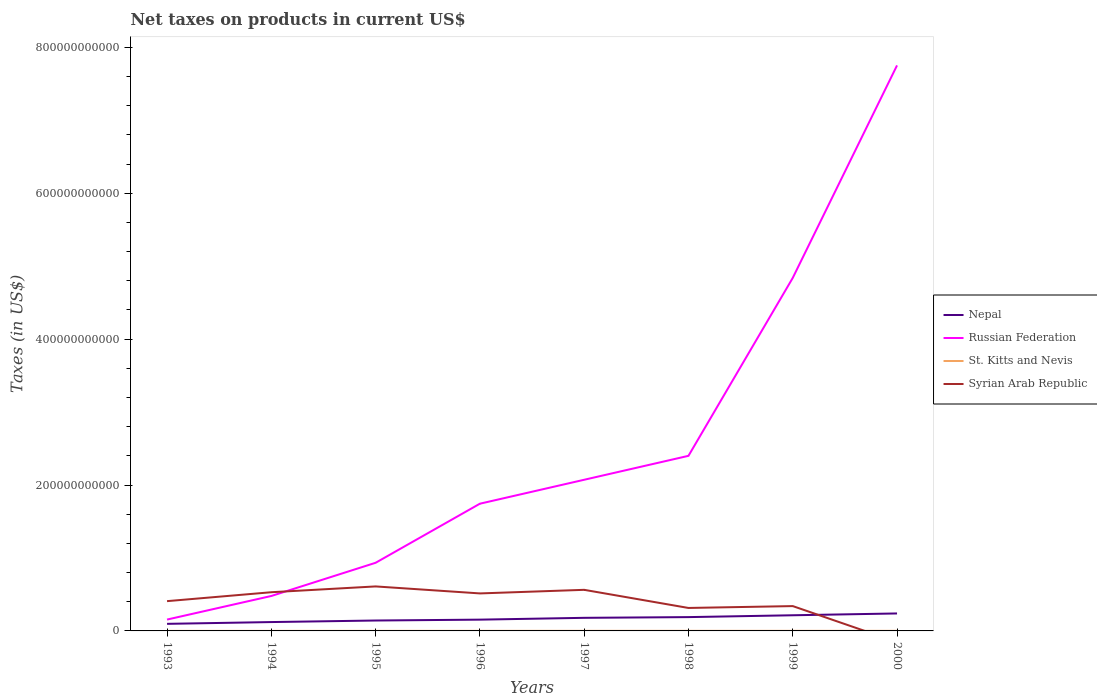Across all years, what is the maximum net taxes on products in St. Kitts and Nevis?
Offer a terse response. 6.36e+07. What is the total net taxes on products in Syrian Arab Republic in the graph?
Your answer should be compact. 9.59e+09. What is the difference between the highest and the second highest net taxes on products in Nepal?
Your answer should be compact. 1.42e+1. What is the difference between the highest and the lowest net taxes on products in St. Kitts and Nevis?
Give a very brief answer. 5. What is the difference between two consecutive major ticks on the Y-axis?
Provide a short and direct response. 2.00e+11. Are the values on the major ticks of Y-axis written in scientific E-notation?
Ensure brevity in your answer.  No. How many legend labels are there?
Keep it short and to the point. 4. What is the title of the graph?
Provide a succinct answer. Net taxes on products in current US$. What is the label or title of the X-axis?
Offer a very short reply. Years. What is the label or title of the Y-axis?
Give a very brief answer. Taxes (in US$). What is the Taxes (in US$) of Nepal in 1993?
Provide a short and direct response. 9.70e+09. What is the Taxes (in US$) in Russian Federation in 1993?
Give a very brief answer. 1.56e+1. What is the Taxes (in US$) in St. Kitts and Nevis in 1993?
Keep it short and to the point. 6.36e+07. What is the Taxes (in US$) in Syrian Arab Republic in 1993?
Your answer should be compact. 4.08e+1. What is the Taxes (in US$) in Nepal in 1994?
Ensure brevity in your answer.  1.21e+1. What is the Taxes (in US$) of Russian Federation in 1994?
Make the answer very short. 4.79e+1. What is the Taxes (in US$) in St. Kitts and Nevis in 1994?
Give a very brief answer. 6.94e+07. What is the Taxes (in US$) in Syrian Arab Republic in 1994?
Provide a short and direct response. 5.30e+1. What is the Taxes (in US$) in Nepal in 1995?
Ensure brevity in your answer.  1.43e+1. What is the Taxes (in US$) of Russian Federation in 1995?
Your response must be concise. 9.34e+1. What is the Taxes (in US$) of St. Kitts and Nevis in 1995?
Keep it short and to the point. 9.47e+07. What is the Taxes (in US$) in Syrian Arab Republic in 1995?
Keep it short and to the point. 6.10e+1. What is the Taxes (in US$) of Nepal in 1996?
Keep it short and to the point. 1.55e+1. What is the Taxes (in US$) in Russian Federation in 1996?
Ensure brevity in your answer.  1.74e+11. What is the Taxes (in US$) in St. Kitts and Nevis in 1996?
Provide a short and direct response. 1.05e+08. What is the Taxes (in US$) of Syrian Arab Republic in 1996?
Your answer should be compact. 5.14e+1. What is the Taxes (in US$) in Nepal in 1997?
Keep it short and to the point. 1.80e+1. What is the Taxes (in US$) of Russian Federation in 1997?
Your answer should be very brief. 2.07e+11. What is the Taxes (in US$) of St. Kitts and Nevis in 1997?
Make the answer very short. 1.19e+08. What is the Taxes (in US$) of Syrian Arab Republic in 1997?
Your response must be concise. 5.63e+1. What is the Taxes (in US$) of Nepal in 1998?
Offer a very short reply. 1.89e+1. What is the Taxes (in US$) in Russian Federation in 1998?
Provide a short and direct response. 2.40e+11. What is the Taxes (in US$) of St. Kitts and Nevis in 1998?
Offer a very short reply. 1.23e+08. What is the Taxes (in US$) in Syrian Arab Republic in 1998?
Your response must be concise. 3.15e+1. What is the Taxes (in US$) in Nepal in 1999?
Offer a very short reply. 2.15e+1. What is the Taxes (in US$) of Russian Federation in 1999?
Offer a very short reply. 4.84e+11. What is the Taxes (in US$) in St. Kitts and Nevis in 1999?
Give a very brief answer. 1.29e+08. What is the Taxes (in US$) in Syrian Arab Republic in 1999?
Your response must be concise. 3.40e+1. What is the Taxes (in US$) in Nepal in 2000?
Your response must be concise. 2.39e+1. What is the Taxes (in US$) in Russian Federation in 2000?
Make the answer very short. 7.75e+11. What is the Taxes (in US$) of St. Kitts and Nevis in 2000?
Your answer should be very brief. 1.19e+08. Across all years, what is the maximum Taxes (in US$) in Nepal?
Your answer should be compact. 2.39e+1. Across all years, what is the maximum Taxes (in US$) in Russian Federation?
Give a very brief answer. 7.75e+11. Across all years, what is the maximum Taxes (in US$) of St. Kitts and Nevis?
Provide a succinct answer. 1.29e+08. Across all years, what is the maximum Taxes (in US$) of Syrian Arab Republic?
Provide a succinct answer. 6.10e+1. Across all years, what is the minimum Taxes (in US$) of Nepal?
Ensure brevity in your answer.  9.70e+09. Across all years, what is the minimum Taxes (in US$) of Russian Federation?
Provide a short and direct response. 1.56e+1. Across all years, what is the minimum Taxes (in US$) in St. Kitts and Nevis?
Your response must be concise. 6.36e+07. What is the total Taxes (in US$) in Nepal in the graph?
Provide a short and direct response. 1.34e+11. What is the total Taxes (in US$) in Russian Federation in the graph?
Offer a terse response. 2.04e+12. What is the total Taxes (in US$) of St. Kitts and Nevis in the graph?
Your response must be concise. 8.23e+08. What is the total Taxes (in US$) in Syrian Arab Republic in the graph?
Your response must be concise. 3.28e+11. What is the difference between the Taxes (in US$) in Nepal in 1993 and that in 1994?
Give a very brief answer. -2.45e+09. What is the difference between the Taxes (in US$) in Russian Federation in 1993 and that in 1994?
Offer a terse response. -3.23e+1. What is the difference between the Taxes (in US$) of St. Kitts and Nevis in 1993 and that in 1994?
Provide a short and direct response. -5.82e+06. What is the difference between the Taxes (in US$) of Syrian Arab Republic in 1993 and that in 1994?
Your answer should be compact. -1.22e+1. What is the difference between the Taxes (in US$) in Nepal in 1993 and that in 1995?
Provide a succinct answer. -4.56e+09. What is the difference between the Taxes (in US$) in Russian Federation in 1993 and that in 1995?
Provide a succinct answer. -7.78e+1. What is the difference between the Taxes (in US$) of St. Kitts and Nevis in 1993 and that in 1995?
Offer a terse response. -3.11e+07. What is the difference between the Taxes (in US$) in Syrian Arab Republic in 1993 and that in 1995?
Provide a short and direct response. -2.02e+1. What is the difference between the Taxes (in US$) of Nepal in 1993 and that in 1996?
Your answer should be very brief. -5.76e+09. What is the difference between the Taxes (in US$) in Russian Federation in 1993 and that in 1996?
Provide a succinct answer. -1.59e+11. What is the difference between the Taxes (in US$) of St. Kitts and Nevis in 1993 and that in 1996?
Your answer should be compact. -4.15e+07. What is the difference between the Taxes (in US$) in Syrian Arab Republic in 1993 and that in 1996?
Your answer should be compact. -1.06e+1. What is the difference between the Taxes (in US$) of Nepal in 1993 and that in 1997?
Make the answer very short. -8.25e+09. What is the difference between the Taxes (in US$) in Russian Federation in 1993 and that in 1997?
Offer a terse response. -1.92e+11. What is the difference between the Taxes (in US$) in St. Kitts and Nevis in 1993 and that in 1997?
Offer a terse response. -5.52e+07. What is the difference between the Taxes (in US$) in Syrian Arab Republic in 1993 and that in 1997?
Offer a very short reply. -1.55e+1. What is the difference between the Taxes (in US$) of Nepal in 1993 and that in 1998?
Ensure brevity in your answer.  -9.24e+09. What is the difference between the Taxes (in US$) in Russian Federation in 1993 and that in 1998?
Make the answer very short. -2.24e+11. What is the difference between the Taxes (in US$) in St. Kitts and Nevis in 1993 and that in 1998?
Provide a short and direct response. -5.97e+07. What is the difference between the Taxes (in US$) of Syrian Arab Republic in 1993 and that in 1998?
Your response must be concise. 9.34e+09. What is the difference between the Taxes (in US$) in Nepal in 1993 and that in 1999?
Offer a terse response. -1.18e+1. What is the difference between the Taxes (in US$) in Russian Federation in 1993 and that in 1999?
Your answer should be very brief. -4.68e+11. What is the difference between the Taxes (in US$) in St. Kitts and Nevis in 1993 and that in 1999?
Make the answer very short. -6.53e+07. What is the difference between the Taxes (in US$) in Syrian Arab Republic in 1993 and that in 1999?
Provide a succinct answer. 6.78e+09. What is the difference between the Taxes (in US$) in Nepal in 1993 and that in 2000?
Keep it short and to the point. -1.42e+1. What is the difference between the Taxes (in US$) in Russian Federation in 1993 and that in 2000?
Offer a terse response. -7.60e+11. What is the difference between the Taxes (in US$) in St. Kitts and Nevis in 1993 and that in 2000?
Make the answer very short. -5.50e+07. What is the difference between the Taxes (in US$) of Nepal in 1994 and that in 1995?
Give a very brief answer. -2.11e+09. What is the difference between the Taxes (in US$) in Russian Federation in 1994 and that in 1995?
Make the answer very short. -4.55e+1. What is the difference between the Taxes (in US$) in St. Kitts and Nevis in 1994 and that in 1995?
Provide a short and direct response. -2.53e+07. What is the difference between the Taxes (in US$) in Syrian Arab Republic in 1994 and that in 1995?
Offer a terse response. -7.96e+09. What is the difference between the Taxes (in US$) in Nepal in 1994 and that in 1996?
Keep it short and to the point. -3.31e+09. What is the difference between the Taxes (in US$) of Russian Federation in 1994 and that in 1996?
Your answer should be compact. -1.27e+11. What is the difference between the Taxes (in US$) of St. Kitts and Nevis in 1994 and that in 1996?
Your answer should be very brief. -3.57e+07. What is the difference between the Taxes (in US$) of Syrian Arab Republic in 1994 and that in 1996?
Your response must be concise. 1.63e+09. What is the difference between the Taxes (in US$) of Nepal in 1994 and that in 1997?
Provide a short and direct response. -5.80e+09. What is the difference between the Taxes (in US$) in Russian Federation in 1994 and that in 1997?
Give a very brief answer. -1.59e+11. What is the difference between the Taxes (in US$) of St. Kitts and Nevis in 1994 and that in 1997?
Offer a terse response. -4.94e+07. What is the difference between the Taxes (in US$) of Syrian Arab Republic in 1994 and that in 1997?
Your answer should be compact. -3.28e+09. What is the difference between the Taxes (in US$) of Nepal in 1994 and that in 1998?
Make the answer very short. -6.79e+09. What is the difference between the Taxes (in US$) of Russian Federation in 1994 and that in 1998?
Your answer should be very brief. -1.92e+11. What is the difference between the Taxes (in US$) in St. Kitts and Nevis in 1994 and that in 1998?
Ensure brevity in your answer.  -5.39e+07. What is the difference between the Taxes (in US$) of Syrian Arab Republic in 1994 and that in 1998?
Provide a short and direct response. 2.16e+1. What is the difference between the Taxes (in US$) in Nepal in 1994 and that in 1999?
Your response must be concise. -9.31e+09. What is the difference between the Taxes (in US$) in Russian Federation in 1994 and that in 1999?
Make the answer very short. -4.36e+11. What is the difference between the Taxes (in US$) of St. Kitts and Nevis in 1994 and that in 1999?
Provide a short and direct response. -5.95e+07. What is the difference between the Taxes (in US$) of Syrian Arab Republic in 1994 and that in 1999?
Give a very brief answer. 1.90e+1. What is the difference between the Taxes (in US$) of Nepal in 1994 and that in 2000?
Your answer should be compact. -1.18e+1. What is the difference between the Taxes (in US$) in Russian Federation in 1994 and that in 2000?
Ensure brevity in your answer.  -7.27e+11. What is the difference between the Taxes (in US$) of St. Kitts and Nevis in 1994 and that in 2000?
Your response must be concise. -4.92e+07. What is the difference between the Taxes (in US$) of Nepal in 1995 and that in 1996?
Make the answer very short. -1.20e+09. What is the difference between the Taxes (in US$) in Russian Federation in 1995 and that in 1996?
Make the answer very short. -8.10e+1. What is the difference between the Taxes (in US$) in St. Kitts and Nevis in 1995 and that in 1996?
Offer a terse response. -1.04e+07. What is the difference between the Taxes (in US$) in Syrian Arab Republic in 1995 and that in 1996?
Ensure brevity in your answer.  9.59e+09. What is the difference between the Taxes (in US$) in Nepal in 1995 and that in 1997?
Keep it short and to the point. -3.69e+09. What is the difference between the Taxes (in US$) in Russian Federation in 1995 and that in 1997?
Provide a short and direct response. -1.14e+11. What is the difference between the Taxes (in US$) in St. Kitts and Nevis in 1995 and that in 1997?
Ensure brevity in your answer.  -2.41e+07. What is the difference between the Taxes (in US$) of Syrian Arab Republic in 1995 and that in 1997?
Give a very brief answer. 4.68e+09. What is the difference between the Taxes (in US$) in Nepal in 1995 and that in 1998?
Keep it short and to the point. -4.68e+09. What is the difference between the Taxes (in US$) of Russian Federation in 1995 and that in 1998?
Ensure brevity in your answer.  -1.47e+11. What is the difference between the Taxes (in US$) in St. Kitts and Nevis in 1995 and that in 1998?
Provide a short and direct response. -2.86e+07. What is the difference between the Taxes (in US$) of Syrian Arab Republic in 1995 and that in 1998?
Keep it short and to the point. 2.95e+1. What is the difference between the Taxes (in US$) of Nepal in 1995 and that in 1999?
Offer a terse response. -7.20e+09. What is the difference between the Taxes (in US$) of Russian Federation in 1995 and that in 1999?
Your answer should be very brief. -3.90e+11. What is the difference between the Taxes (in US$) of St. Kitts and Nevis in 1995 and that in 1999?
Your response must be concise. -3.42e+07. What is the difference between the Taxes (in US$) in Syrian Arab Republic in 1995 and that in 1999?
Provide a succinct answer. 2.70e+1. What is the difference between the Taxes (in US$) of Nepal in 1995 and that in 2000?
Give a very brief answer. -9.68e+09. What is the difference between the Taxes (in US$) of Russian Federation in 1995 and that in 2000?
Offer a very short reply. -6.82e+11. What is the difference between the Taxes (in US$) in St. Kitts and Nevis in 1995 and that in 2000?
Ensure brevity in your answer.  -2.39e+07. What is the difference between the Taxes (in US$) of Nepal in 1996 and that in 1997?
Your answer should be very brief. -2.50e+09. What is the difference between the Taxes (in US$) of Russian Federation in 1996 and that in 1997?
Your response must be concise. -3.28e+1. What is the difference between the Taxes (in US$) of St. Kitts and Nevis in 1996 and that in 1997?
Make the answer very short. -1.37e+07. What is the difference between the Taxes (in US$) in Syrian Arab Republic in 1996 and that in 1997?
Keep it short and to the point. -4.91e+09. What is the difference between the Taxes (in US$) of Nepal in 1996 and that in 1998?
Give a very brief answer. -3.49e+09. What is the difference between the Taxes (in US$) in Russian Federation in 1996 and that in 1998?
Your response must be concise. -6.56e+1. What is the difference between the Taxes (in US$) of St. Kitts and Nevis in 1996 and that in 1998?
Your answer should be compact. -1.82e+07. What is the difference between the Taxes (in US$) of Syrian Arab Republic in 1996 and that in 1998?
Provide a succinct answer. 1.99e+1. What is the difference between the Taxes (in US$) of Nepal in 1996 and that in 1999?
Offer a very short reply. -6.00e+09. What is the difference between the Taxes (in US$) in Russian Federation in 1996 and that in 1999?
Your response must be concise. -3.10e+11. What is the difference between the Taxes (in US$) of St. Kitts and Nevis in 1996 and that in 1999?
Keep it short and to the point. -2.38e+07. What is the difference between the Taxes (in US$) of Syrian Arab Republic in 1996 and that in 1999?
Offer a very short reply. 1.74e+1. What is the difference between the Taxes (in US$) in Nepal in 1996 and that in 2000?
Your response must be concise. -8.49e+09. What is the difference between the Taxes (in US$) in Russian Federation in 1996 and that in 2000?
Your answer should be compact. -6.01e+11. What is the difference between the Taxes (in US$) in St. Kitts and Nevis in 1996 and that in 2000?
Give a very brief answer. -1.35e+07. What is the difference between the Taxes (in US$) in Nepal in 1997 and that in 1998?
Make the answer very short. -9.91e+08. What is the difference between the Taxes (in US$) of Russian Federation in 1997 and that in 1998?
Ensure brevity in your answer.  -3.28e+1. What is the difference between the Taxes (in US$) in St. Kitts and Nevis in 1997 and that in 1998?
Make the answer very short. -4.53e+06. What is the difference between the Taxes (in US$) in Syrian Arab Republic in 1997 and that in 1998?
Provide a succinct answer. 2.49e+1. What is the difference between the Taxes (in US$) of Nepal in 1997 and that in 1999?
Provide a succinct answer. -3.50e+09. What is the difference between the Taxes (in US$) of Russian Federation in 1997 and that in 1999?
Offer a terse response. -2.77e+11. What is the difference between the Taxes (in US$) in St. Kitts and Nevis in 1997 and that in 1999?
Give a very brief answer. -1.01e+07. What is the difference between the Taxes (in US$) of Syrian Arab Republic in 1997 and that in 1999?
Your response must be concise. 2.23e+1. What is the difference between the Taxes (in US$) in Nepal in 1997 and that in 2000?
Make the answer very short. -5.99e+09. What is the difference between the Taxes (in US$) in Russian Federation in 1997 and that in 2000?
Provide a succinct answer. -5.68e+11. What is the difference between the Taxes (in US$) in St. Kitts and Nevis in 1997 and that in 2000?
Keep it short and to the point. 1.90e+05. What is the difference between the Taxes (in US$) in Nepal in 1998 and that in 1999?
Provide a succinct answer. -2.51e+09. What is the difference between the Taxes (in US$) of Russian Federation in 1998 and that in 1999?
Offer a terse response. -2.44e+11. What is the difference between the Taxes (in US$) in St. Kitts and Nevis in 1998 and that in 1999?
Keep it short and to the point. -5.56e+06. What is the difference between the Taxes (in US$) of Syrian Arab Republic in 1998 and that in 1999?
Your answer should be very brief. -2.56e+09. What is the difference between the Taxes (in US$) in Nepal in 1998 and that in 2000?
Give a very brief answer. -5.00e+09. What is the difference between the Taxes (in US$) of Russian Federation in 1998 and that in 2000?
Keep it short and to the point. -5.35e+11. What is the difference between the Taxes (in US$) of St. Kitts and Nevis in 1998 and that in 2000?
Give a very brief answer. 4.72e+06. What is the difference between the Taxes (in US$) in Nepal in 1999 and that in 2000?
Keep it short and to the point. -2.49e+09. What is the difference between the Taxes (in US$) of Russian Federation in 1999 and that in 2000?
Provide a succinct answer. -2.91e+11. What is the difference between the Taxes (in US$) in St. Kitts and Nevis in 1999 and that in 2000?
Ensure brevity in your answer.  1.03e+07. What is the difference between the Taxes (in US$) in Nepal in 1993 and the Taxes (in US$) in Russian Federation in 1994?
Make the answer very short. -3.82e+1. What is the difference between the Taxes (in US$) of Nepal in 1993 and the Taxes (in US$) of St. Kitts and Nevis in 1994?
Ensure brevity in your answer.  9.63e+09. What is the difference between the Taxes (in US$) in Nepal in 1993 and the Taxes (in US$) in Syrian Arab Republic in 1994?
Your answer should be very brief. -4.33e+1. What is the difference between the Taxes (in US$) in Russian Federation in 1993 and the Taxes (in US$) in St. Kitts and Nevis in 1994?
Offer a very short reply. 1.55e+1. What is the difference between the Taxes (in US$) in Russian Federation in 1993 and the Taxes (in US$) in Syrian Arab Republic in 1994?
Your answer should be very brief. -3.75e+1. What is the difference between the Taxes (in US$) of St. Kitts and Nevis in 1993 and the Taxes (in US$) of Syrian Arab Republic in 1994?
Keep it short and to the point. -5.30e+1. What is the difference between the Taxes (in US$) of Nepal in 1993 and the Taxes (in US$) of Russian Federation in 1995?
Provide a succinct answer. -8.37e+1. What is the difference between the Taxes (in US$) of Nepal in 1993 and the Taxes (in US$) of St. Kitts and Nevis in 1995?
Your answer should be very brief. 9.61e+09. What is the difference between the Taxes (in US$) in Nepal in 1993 and the Taxes (in US$) in Syrian Arab Republic in 1995?
Provide a short and direct response. -5.13e+1. What is the difference between the Taxes (in US$) in Russian Federation in 1993 and the Taxes (in US$) in St. Kitts and Nevis in 1995?
Ensure brevity in your answer.  1.55e+1. What is the difference between the Taxes (in US$) of Russian Federation in 1993 and the Taxes (in US$) of Syrian Arab Republic in 1995?
Give a very brief answer. -4.54e+1. What is the difference between the Taxes (in US$) in St. Kitts and Nevis in 1993 and the Taxes (in US$) in Syrian Arab Republic in 1995?
Offer a terse response. -6.09e+1. What is the difference between the Taxes (in US$) in Nepal in 1993 and the Taxes (in US$) in Russian Federation in 1996?
Your response must be concise. -1.65e+11. What is the difference between the Taxes (in US$) of Nepal in 1993 and the Taxes (in US$) of St. Kitts and Nevis in 1996?
Ensure brevity in your answer.  9.60e+09. What is the difference between the Taxes (in US$) in Nepal in 1993 and the Taxes (in US$) in Syrian Arab Republic in 1996?
Offer a very short reply. -4.17e+1. What is the difference between the Taxes (in US$) in Russian Federation in 1993 and the Taxes (in US$) in St. Kitts and Nevis in 1996?
Ensure brevity in your answer.  1.55e+1. What is the difference between the Taxes (in US$) of Russian Federation in 1993 and the Taxes (in US$) of Syrian Arab Republic in 1996?
Provide a short and direct response. -3.59e+1. What is the difference between the Taxes (in US$) of St. Kitts and Nevis in 1993 and the Taxes (in US$) of Syrian Arab Republic in 1996?
Keep it short and to the point. -5.13e+1. What is the difference between the Taxes (in US$) of Nepal in 1993 and the Taxes (in US$) of Russian Federation in 1997?
Your answer should be compact. -1.97e+11. What is the difference between the Taxes (in US$) in Nepal in 1993 and the Taxes (in US$) in St. Kitts and Nevis in 1997?
Your answer should be very brief. 9.58e+09. What is the difference between the Taxes (in US$) in Nepal in 1993 and the Taxes (in US$) in Syrian Arab Republic in 1997?
Your answer should be compact. -4.66e+1. What is the difference between the Taxes (in US$) of Russian Federation in 1993 and the Taxes (in US$) of St. Kitts and Nevis in 1997?
Provide a short and direct response. 1.54e+1. What is the difference between the Taxes (in US$) in Russian Federation in 1993 and the Taxes (in US$) in Syrian Arab Republic in 1997?
Offer a terse response. -4.08e+1. What is the difference between the Taxes (in US$) of St. Kitts and Nevis in 1993 and the Taxes (in US$) of Syrian Arab Republic in 1997?
Make the answer very short. -5.63e+1. What is the difference between the Taxes (in US$) of Nepal in 1993 and the Taxes (in US$) of Russian Federation in 1998?
Provide a succinct answer. -2.30e+11. What is the difference between the Taxes (in US$) in Nepal in 1993 and the Taxes (in US$) in St. Kitts and Nevis in 1998?
Ensure brevity in your answer.  9.58e+09. What is the difference between the Taxes (in US$) of Nepal in 1993 and the Taxes (in US$) of Syrian Arab Republic in 1998?
Provide a succinct answer. -2.18e+1. What is the difference between the Taxes (in US$) in Russian Federation in 1993 and the Taxes (in US$) in St. Kitts and Nevis in 1998?
Your answer should be very brief. 1.54e+1. What is the difference between the Taxes (in US$) in Russian Federation in 1993 and the Taxes (in US$) in Syrian Arab Republic in 1998?
Your answer should be very brief. -1.59e+1. What is the difference between the Taxes (in US$) in St. Kitts and Nevis in 1993 and the Taxes (in US$) in Syrian Arab Republic in 1998?
Make the answer very short. -3.14e+1. What is the difference between the Taxes (in US$) in Nepal in 1993 and the Taxes (in US$) in Russian Federation in 1999?
Make the answer very short. -4.74e+11. What is the difference between the Taxes (in US$) of Nepal in 1993 and the Taxes (in US$) of St. Kitts and Nevis in 1999?
Your response must be concise. 9.57e+09. What is the difference between the Taxes (in US$) in Nepal in 1993 and the Taxes (in US$) in Syrian Arab Republic in 1999?
Give a very brief answer. -2.43e+1. What is the difference between the Taxes (in US$) of Russian Federation in 1993 and the Taxes (in US$) of St. Kitts and Nevis in 1999?
Offer a very short reply. 1.54e+1. What is the difference between the Taxes (in US$) in Russian Federation in 1993 and the Taxes (in US$) in Syrian Arab Republic in 1999?
Make the answer very short. -1.85e+1. What is the difference between the Taxes (in US$) of St. Kitts and Nevis in 1993 and the Taxes (in US$) of Syrian Arab Republic in 1999?
Ensure brevity in your answer.  -3.40e+1. What is the difference between the Taxes (in US$) of Nepal in 1993 and the Taxes (in US$) of Russian Federation in 2000?
Give a very brief answer. -7.65e+11. What is the difference between the Taxes (in US$) of Nepal in 1993 and the Taxes (in US$) of St. Kitts and Nevis in 2000?
Provide a succinct answer. 9.58e+09. What is the difference between the Taxes (in US$) in Russian Federation in 1993 and the Taxes (in US$) in St. Kitts and Nevis in 2000?
Your response must be concise. 1.54e+1. What is the difference between the Taxes (in US$) in Nepal in 1994 and the Taxes (in US$) in Russian Federation in 1995?
Provide a short and direct response. -8.13e+1. What is the difference between the Taxes (in US$) in Nepal in 1994 and the Taxes (in US$) in St. Kitts and Nevis in 1995?
Give a very brief answer. 1.21e+1. What is the difference between the Taxes (in US$) in Nepal in 1994 and the Taxes (in US$) in Syrian Arab Republic in 1995?
Offer a terse response. -4.89e+1. What is the difference between the Taxes (in US$) of Russian Federation in 1994 and the Taxes (in US$) of St. Kitts and Nevis in 1995?
Give a very brief answer. 4.78e+1. What is the difference between the Taxes (in US$) of Russian Federation in 1994 and the Taxes (in US$) of Syrian Arab Republic in 1995?
Your response must be concise. -1.31e+1. What is the difference between the Taxes (in US$) of St. Kitts and Nevis in 1994 and the Taxes (in US$) of Syrian Arab Republic in 1995?
Your response must be concise. -6.09e+1. What is the difference between the Taxes (in US$) of Nepal in 1994 and the Taxes (in US$) of Russian Federation in 1996?
Make the answer very short. -1.62e+11. What is the difference between the Taxes (in US$) in Nepal in 1994 and the Taxes (in US$) in St. Kitts and Nevis in 1996?
Offer a terse response. 1.20e+1. What is the difference between the Taxes (in US$) of Nepal in 1994 and the Taxes (in US$) of Syrian Arab Republic in 1996?
Keep it short and to the point. -3.93e+1. What is the difference between the Taxes (in US$) in Russian Federation in 1994 and the Taxes (in US$) in St. Kitts and Nevis in 1996?
Give a very brief answer. 4.78e+1. What is the difference between the Taxes (in US$) in Russian Federation in 1994 and the Taxes (in US$) in Syrian Arab Republic in 1996?
Provide a succinct answer. -3.51e+09. What is the difference between the Taxes (in US$) in St. Kitts and Nevis in 1994 and the Taxes (in US$) in Syrian Arab Republic in 1996?
Keep it short and to the point. -5.13e+1. What is the difference between the Taxes (in US$) of Nepal in 1994 and the Taxes (in US$) of Russian Federation in 1997?
Your response must be concise. -1.95e+11. What is the difference between the Taxes (in US$) of Nepal in 1994 and the Taxes (in US$) of St. Kitts and Nevis in 1997?
Provide a short and direct response. 1.20e+1. What is the difference between the Taxes (in US$) in Nepal in 1994 and the Taxes (in US$) in Syrian Arab Republic in 1997?
Provide a succinct answer. -4.42e+1. What is the difference between the Taxes (in US$) in Russian Federation in 1994 and the Taxes (in US$) in St. Kitts and Nevis in 1997?
Provide a succinct answer. 4.78e+1. What is the difference between the Taxes (in US$) in Russian Federation in 1994 and the Taxes (in US$) in Syrian Arab Republic in 1997?
Your answer should be very brief. -8.43e+09. What is the difference between the Taxes (in US$) in St. Kitts and Nevis in 1994 and the Taxes (in US$) in Syrian Arab Republic in 1997?
Your response must be concise. -5.63e+1. What is the difference between the Taxes (in US$) in Nepal in 1994 and the Taxes (in US$) in Russian Federation in 1998?
Keep it short and to the point. -2.28e+11. What is the difference between the Taxes (in US$) of Nepal in 1994 and the Taxes (in US$) of St. Kitts and Nevis in 1998?
Make the answer very short. 1.20e+1. What is the difference between the Taxes (in US$) in Nepal in 1994 and the Taxes (in US$) in Syrian Arab Republic in 1998?
Keep it short and to the point. -1.93e+1. What is the difference between the Taxes (in US$) of Russian Federation in 1994 and the Taxes (in US$) of St. Kitts and Nevis in 1998?
Offer a terse response. 4.78e+1. What is the difference between the Taxes (in US$) of Russian Federation in 1994 and the Taxes (in US$) of Syrian Arab Republic in 1998?
Offer a terse response. 1.64e+1. What is the difference between the Taxes (in US$) in St. Kitts and Nevis in 1994 and the Taxes (in US$) in Syrian Arab Republic in 1998?
Your answer should be very brief. -3.14e+1. What is the difference between the Taxes (in US$) in Nepal in 1994 and the Taxes (in US$) in Russian Federation in 1999?
Your answer should be compact. -4.72e+11. What is the difference between the Taxes (in US$) of Nepal in 1994 and the Taxes (in US$) of St. Kitts and Nevis in 1999?
Your response must be concise. 1.20e+1. What is the difference between the Taxes (in US$) in Nepal in 1994 and the Taxes (in US$) in Syrian Arab Republic in 1999?
Offer a very short reply. -2.19e+1. What is the difference between the Taxes (in US$) of Russian Federation in 1994 and the Taxes (in US$) of St. Kitts and Nevis in 1999?
Offer a very short reply. 4.78e+1. What is the difference between the Taxes (in US$) of Russian Federation in 1994 and the Taxes (in US$) of Syrian Arab Republic in 1999?
Offer a very short reply. 1.39e+1. What is the difference between the Taxes (in US$) of St. Kitts and Nevis in 1994 and the Taxes (in US$) of Syrian Arab Republic in 1999?
Provide a short and direct response. -3.40e+1. What is the difference between the Taxes (in US$) in Nepal in 1994 and the Taxes (in US$) in Russian Federation in 2000?
Keep it short and to the point. -7.63e+11. What is the difference between the Taxes (in US$) of Nepal in 1994 and the Taxes (in US$) of St. Kitts and Nevis in 2000?
Provide a succinct answer. 1.20e+1. What is the difference between the Taxes (in US$) of Russian Federation in 1994 and the Taxes (in US$) of St. Kitts and Nevis in 2000?
Your response must be concise. 4.78e+1. What is the difference between the Taxes (in US$) in Nepal in 1995 and the Taxes (in US$) in Russian Federation in 1996?
Give a very brief answer. -1.60e+11. What is the difference between the Taxes (in US$) of Nepal in 1995 and the Taxes (in US$) of St. Kitts and Nevis in 1996?
Give a very brief answer. 1.42e+1. What is the difference between the Taxes (in US$) of Nepal in 1995 and the Taxes (in US$) of Syrian Arab Republic in 1996?
Your answer should be compact. -3.72e+1. What is the difference between the Taxes (in US$) in Russian Federation in 1995 and the Taxes (in US$) in St. Kitts and Nevis in 1996?
Give a very brief answer. 9.33e+1. What is the difference between the Taxes (in US$) in Russian Federation in 1995 and the Taxes (in US$) in Syrian Arab Republic in 1996?
Keep it short and to the point. 4.20e+1. What is the difference between the Taxes (in US$) in St. Kitts and Nevis in 1995 and the Taxes (in US$) in Syrian Arab Republic in 1996?
Provide a succinct answer. -5.13e+1. What is the difference between the Taxes (in US$) of Nepal in 1995 and the Taxes (in US$) of Russian Federation in 1997?
Keep it short and to the point. -1.93e+11. What is the difference between the Taxes (in US$) of Nepal in 1995 and the Taxes (in US$) of St. Kitts and Nevis in 1997?
Provide a short and direct response. 1.41e+1. What is the difference between the Taxes (in US$) of Nepal in 1995 and the Taxes (in US$) of Syrian Arab Republic in 1997?
Provide a succinct answer. -4.21e+1. What is the difference between the Taxes (in US$) in Russian Federation in 1995 and the Taxes (in US$) in St. Kitts and Nevis in 1997?
Your response must be concise. 9.33e+1. What is the difference between the Taxes (in US$) in Russian Federation in 1995 and the Taxes (in US$) in Syrian Arab Republic in 1997?
Offer a very short reply. 3.71e+1. What is the difference between the Taxes (in US$) of St. Kitts and Nevis in 1995 and the Taxes (in US$) of Syrian Arab Republic in 1997?
Your answer should be very brief. -5.62e+1. What is the difference between the Taxes (in US$) of Nepal in 1995 and the Taxes (in US$) of Russian Federation in 1998?
Offer a terse response. -2.26e+11. What is the difference between the Taxes (in US$) in Nepal in 1995 and the Taxes (in US$) in St. Kitts and Nevis in 1998?
Provide a short and direct response. 1.41e+1. What is the difference between the Taxes (in US$) of Nepal in 1995 and the Taxes (in US$) of Syrian Arab Republic in 1998?
Ensure brevity in your answer.  -1.72e+1. What is the difference between the Taxes (in US$) in Russian Federation in 1995 and the Taxes (in US$) in St. Kitts and Nevis in 1998?
Give a very brief answer. 9.33e+1. What is the difference between the Taxes (in US$) of Russian Federation in 1995 and the Taxes (in US$) of Syrian Arab Republic in 1998?
Give a very brief answer. 6.19e+1. What is the difference between the Taxes (in US$) in St. Kitts and Nevis in 1995 and the Taxes (in US$) in Syrian Arab Republic in 1998?
Offer a very short reply. -3.14e+1. What is the difference between the Taxes (in US$) of Nepal in 1995 and the Taxes (in US$) of Russian Federation in 1999?
Keep it short and to the point. -4.70e+11. What is the difference between the Taxes (in US$) in Nepal in 1995 and the Taxes (in US$) in St. Kitts and Nevis in 1999?
Your response must be concise. 1.41e+1. What is the difference between the Taxes (in US$) in Nepal in 1995 and the Taxes (in US$) in Syrian Arab Republic in 1999?
Provide a succinct answer. -1.98e+1. What is the difference between the Taxes (in US$) of Russian Federation in 1995 and the Taxes (in US$) of St. Kitts and Nevis in 1999?
Offer a terse response. 9.33e+1. What is the difference between the Taxes (in US$) in Russian Federation in 1995 and the Taxes (in US$) in Syrian Arab Republic in 1999?
Offer a terse response. 5.94e+1. What is the difference between the Taxes (in US$) of St. Kitts and Nevis in 1995 and the Taxes (in US$) of Syrian Arab Republic in 1999?
Offer a terse response. -3.39e+1. What is the difference between the Taxes (in US$) in Nepal in 1995 and the Taxes (in US$) in Russian Federation in 2000?
Offer a very short reply. -7.61e+11. What is the difference between the Taxes (in US$) of Nepal in 1995 and the Taxes (in US$) of St. Kitts and Nevis in 2000?
Your answer should be compact. 1.41e+1. What is the difference between the Taxes (in US$) of Russian Federation in 1995 and the Taxes (in US$) of St. Kitts and Nevis in 2000?
Offer a very short reply. 9.33e+1. What is the difference between the Taxes (in US$) in Nepal in 1996 and the Taxes (in US$) in Russian Federation in 1997?
Offer a very short reply. -1.92e+11. What is the difference between the Taxes (in US$) of Nepal in 1996 and the Taxes (in US$) of St. Kitts and Nevis in 1997?
Provide a short and direct response. 1.53e+1. What is the difference between the Taxes (in US$) in Nepal in 1996 and the Taxes (in US$) in Syrian Arab Republic in 1997?
Make the answer very short. -4.09e+1. What is the difference between the Taxes (in US$) in Russian Federation in 1996 and the Taxes (in US$) in St. Kitts and Nevis in 1997?
Offer a terse response. 1.74e+11. What is the difference between the Taxes (in US$) of Russian Federation in 1996 and the Taxes (in US$) of Syrian Arab Republic in 1997?
Provide a succinct answer. 1.18e+11. What is the difference between the Taxes (in US$) in St. Kitts and Nevis in 1996 and the Taxes (in US$) in Syrian Arab Republic in 1997?
Offer a very short reply. -5.62e+1. What is the difference between the Taxes (in US$) in Nepal in 1996 and the Taxes (in US$) in Russian Federation in 1998?
Make the answer very short. -2.25e+11. What is the difference between the Taxes (in US$) in Nepal in 1996 and the Taxes (in US$) in St. Kitts and Nevis in 1998?
Ensure brevity in your answer.  1.53e+1. What is the difference between the Taxes (in US$) in Nepal in 1996 and the Taxes (in US$) in Syrian Arab Republic in 1998?
Give a very brief answer. -1.60e+1. What is the difference between the Taxes (in US$) in Russian Federation in 1996 and the Taxes (in US$) in St. Kitts and Nevis in 1998?
Your answer should be very brief. 1.74e+11. What is the difference between the Taxes (in US$) in Russian Federation in 1996 and the Taxes (in US$) in Syrian Arab Republic in 1998?
Your answer should be compact. 1.43e+11. What is the difference between the Taxes (in US$) of St. Kitts and Nevis in 1996 and the Taxes (in US$) of Syrian Arab Republic in 1998?
Give a very brief answer. -3.14e+1. What is the difference between the Taxes (in US$) in Nepal in 1996 and the Taxes (in US$) in Russian Federation in 1999?
Your answer should be very brief. -4.68e+11. What is the difference between the Taxes (in US$) in Nepal in 1996 and the Taxes (in US$) in St. Kitts and Nevis in 1999?
Make the answer very short. 1.53e+1. What is the difference between the Taxes (in US$) of Nepal in 1996 and the Taxes (in US$) of Syrian Arab Republic in 1999?
Your response must be concise. -1.86e+1. What is the difference between the Taxes (in US$) of Russian Federation in 1996 and the Taxes (in US$) of St. Kitts and Nevis in 1999?
Your response must be concise. 1.74e+11. What is the difference between the Taxes (in US$) in Russian Federation in 1996 and the Taxes (in US$) in Syrian Arab Republic in 1999?
Offer a terse response. 1.40e+11. What is the difference between the Taxes (in US$) in St. Kitts and Nevis in 1996 and the Taxes (in US$) in Syrian Arab Republic in 1999?
Your answer should be very brief. -3.39e+1. What is the difference between the Taxes (in US$) in Nepal in 1996 and the Taxes (in US$) in Russian Federation in 2000?
Your answer should be compact. -7.60e+11. What is the difference between the Taxes (in US$) of Nepal in 1996 and the Taxes (in US$) of St. Kitts and Nevis in 2000?
Give a very brief answer. 1.53e+1. What is the difference between the Taxes (in US$) in Russian Federation in 1996 and the Taxes (in US$) in St. Kitts and Nevis in 2000?
Offer a terse response. 1.74e+11. What is the difference between the Taxes (in US$) of Nepal in 1997 and the Taxes (in US$) of Russian Federation in 1998?
Make the answer very short. -2.22e+11. What is the difference between the Taxes (in US$) of Nepal in 1997 and the Taxes (in US$) of St. Kitts and Nevis in 1998?
Your answer should be compact. 1.78e+1. What is the difference between the Taxes (in US$) in Nepal in 1997 and the Taxes (in US$) in Syrian Arab Republic in 1998?
Your answer should be very brief. -1.35e+1. What is the difference between the Taxes (in US$) in Russian Federation in 1997 and the Taxes (in US$) in St. Kitts and Nevis in 1998?
Provide a succinct answer. 2.07e+11. What is the difference between the Taxes (in US$) of Russian Federation in 1997 and the Taxes (in US$) of Syrian Arab Republic in 1998?
Offer a very short reply. 1.76e+11. What is the difference between the Taxes (in US$) of St. Kitts and Nevis in 1997 and the Taxes (in US$) of Syrian Arab Republic in 1998?
Keep it short and to the point. -3.14e+1. What is the difference between the Taxes (in US$) in Nepal in 1997 and the Taxes (in US$) in Russian Federation in 1999?
Ensure brevity in your answer.  -4.66e+11. What is the difference between the Taxes (in US$) of Nepal in 1997 and the Taxes (in US$) of St. Kitts and Nevis in 1999?
Your response must be concise. 1.78e+1. What is the difference between the Taxes (in US$) of Nepal in 1997 and the Taxes (in US$) of Syrian Arab Republic in 1999?
Provide a succinct answer. -1.61e+1. What is the difference between the Taxes (in US$) of Russian Federation in 1997 and the Taxes (in US$) of St. Kitts and Nevis in 1999?
Give a very brief answer. 2.07e+11. What is the difference between the Taxes (in US$) in Russian Federation in 1997 and the Taxes (in US$) in Syrian Arab Republic in 1999?
Provide a short and direct response. 1.73e+11. What is the difference between the Taxes (in US$) in St. Kitts and Nevis in 1997 and the Taxes (in US$) in Syrian Arab Republic in 1999?
Provide a succinct answer. -3.39e+1. What is the difference between the Taxes (in US$) in Nepal in 1997 and the Taxes (in US$) in Russian Federation in 2000?
Ensure brevity in your answer.  -7.57e+11. What is the difference between the Taxes (in US$) in Nepal in 1997 and the Taxes (in US$) in St. Kitts and Nevis in 2000?
Ensure brevity in your answer.  1.78e+1. What is the difference between the Taxes (in US$) in Russian Federation in 1997 and the Taxes (in US$) in St. Kitts and Nevis in 2000?
Your answer should be compact. 2.07e+11. What is the difference between the Taxes (in US$) in Nepal in 1998 and the Taxes (in US$) in Russian Federation in 1999?
Provide a succinct answer. -4.65e+11. What is the difference between the Taxes (in US$) in Nepal in 1998 and the Taxes (in US$) in St. Kitts and Nevis in 1999?
Your answer should be very brief. 1.88e+1. What is the difference between the Taxes (in US$) in Nepal in 1998 and the Taxes (in US$) in Syrian Arab Republic in 1999?
Provide a succinct answer. -1.51e+1. What is the difference between the Taxes (in US$) of Russian Federation in 1998 and the Taxes (in US$) of St. Kitts and Nevis in 1999?
Make the answer very short. 2.40e+11. What is the difference between the Taxes (in US$) of Russian Federation in 1998 and the Taxes (in US$) of Syrian Arab Republic in 1999?
Offer a very short reply. 2.06e+11. What is the difference between the Taxes (in US$) in St. Kitts and Nevis in 1998 and the Taxes (in US$) in Syrian Arab Republic in 1999?
Your response must be concise. -3.39e+1. What is the difference between the Taxes (in US$) in Nepal in 1998 and the Taxes (in US$) in Russian Federation in 2000?
Provide a short and direct response. -7.56e+11. What is the difference between the Taxes (in US$) in Nepal in 1998 and the Taxes (in US$) in St. Kitts and Nevis in 2000?
Ensure brevity in your answer.  1.88e+1. What is the difference between the Taxes (in US$) in Russian Federation in 1998 and the Taxes (in US$) in St. Kitts and Nevis in 2000?
Offer a terse response. 2.40e+11. What is the difference between the Taxes (in US$) in Nepal in 1999 and the Taxes (in US$) in Russian Federation in 2000?
Offer a very short reply. -7.54e+11. What is the difference between the Taxes (in US$) of Nepal in 1999 and the Taxes (in US$) of St. Kitts and Nevis in 2000?
Your response must be concise. 2.13e+1. What is the difference between the Taxes (in US$) of Russian Federation in 1999 and the Taxes (in US$) of St. Kitts and Nevis in 2000?
Provide a succinct answer. 4.84e+11. What is the average Taxes (in US$) in Nepal per year?
Ensure brevity in your answer.  1.67e+1. What is the average Taxes (in US$) in Russian Federation per year?
Your answer should be very brief. 2.55e+11. What is the average Taxes (in US$) of St. Kitts and Nevis per year?
Give a very brief answer. 1.03e+08. What is the average Taxes (in US$) of Syrian Arab Republic per year?
Offer a very short reply. 4.10e+1. In the year 1993, what is the difference between the Taxes (in US$) in Nepal and Taxes (in US$) in Russian Federation?
Make the answer very short. -5.86e+09. In the year 1993, what is the difference between the Taxes (in US$) in Nepal and Taxes (in US$) in St. Kitts and Nevis?
Make the answer very short. 9.64e+09. In the year 1993, what is the difference between the Taxes (in US$) in Nepal and Taxes (in US$) in Syrian Arab Republic?
Offer a very short reply. -3.11e+1. In the year 1993, what is the difference between the Taxes (in US$) in Russian Federation and Taxes (in US$) in St. Kitts and Nevis?
Your answer should be very brief. 1.55e+1. In the year 1993, what is the difference between the Taxes (in US$) in Russian Federation and Taxes (in US$) in Syrian Arab Republic?
Your answer should be compact. -2.53e+1. In the year 1993, what is the difference between the Taxes (in US$) in St. Kitts and Nevis and Taxes (in US$) in Syrian Arab Republic?
Your response must be concise. -4.07e+1. In the year 1994, what is the difference between the Taxes (in US$) of Nepal and Taxes (in US$) of Russian Federation?
Make the answer very short. -3.57e+1. In the year 1994, what is the difference between the Taxes (in US$) in Nepal and Taxes (in US$) in St. Kitts and Nevis?
Make the answer very short. 1.21e+1. In the year 1994, what is the difference between the Taxes (in US$) of Nepal and Taxes (in US$) of Syrian Arab Republic?
Your answer should be compact. -4.09e+1. In the year 1994, what is the difference between the Taxes (in US$) in Russian Federation and Taxes (in US$) in St. Kitts and Nevis?
Offer a very short reply. 4.78e+1. In the year 1994, what is the difference between the Taxes (in US$) of Russian Federation and Taxes (in US$) of Syrian Arab Republic?
Provide a short and direct response. -5.15e+09. In the year 1994, what is the difference between the Taxes (in US$) of St. Kitts and Nevis and Taxes (in US$) of Syrian Arab Republic?
Your response must be concise. -5.30e+1. In the year 1995, what is the difference between the Taxes (in US$) of Nepal and Taxes (in US$) of Russian Federation?
Your answer should be very brief. -7.91e+1. In the year 1995, what is the difference between the Taxes (in US$) of Nepal and Taxes (in US$) of St. Kitts and Nevis?
Provide a succinct answer. 1.42e+1. In the year 1995, what is the difference between the Taxes (in US$) in Nepal and Taxes (in US$) in Syrian Arab Republic?
Your answer should be very brief. -4.67e+1. In the year 1995, what is the difference between the Taxes (in US$) in Russian Federation and Taxes (in US$) in St. Kitts and Nevis?
Give a very brief answer. 9.33e+1. In the year 1995, what is the difference between the Taxes (in US$) of Russian Federation and Taxes (in US$) of Syrian Arab Republic?
Offer a terse response. 3.24e+1. In the year 1995, what is the difference between the Taxes (in US$) in St. Kitts and Nevis and Taxes (in US$) in Syrian Arab Republic?
Your response must be concise. -6.09e+1. In the year 1996, what is the difference between the Taxes (in US$) in Nepal and Taxes (in US$) in Russian Federation?
Provide a succinct answer. -1.59e+11. In the year 1996, what is the difference between the Taxes (in US$) in Nepal and Taxes (in US$) in St. Kitts and Nevis?
Offer a terse response. 1.54e+1. In the year 1996, what is the difference between the Taxes (in US$) in Nepal and Taxes (in US$) in Syrian Arab Republic?
Your response must be concise. -3.60e+1. In the year 1996, what is the difference between the Taxes (in US$) of Russian Federation and Taxes (in US$) of St. Kitts and Nevis?
Provide a short and direct response. 1.74e+11. In the year 1996, what is the difference between the Taxes (in US$) in Russian Federation and Taxes (in US$) in Syrian Arab Republic?
Offer a terse response. 1.23e+11. In the year 1996, what is the difference between the Taxes (in US$) of St. Kitts and Nevis and Taxes (in US$) of Syrian Arab Republic?
Offer a terse response. -5.13e+1. In the year 1997, what is the difference between the Taxes (in US$) of Nepal and Taxes (in US$) of Russian Federation?
Offer a terse response. -1.89e+11. In the year 1997, what is the difference between the Taxes (in US$) of Nepal and Taxes (in US$) of St. Kitts and Nevis?
Keep it short and to the point. 1.78e+1. In the year 1997, what is the difference between the Taxes (in US$) of Nepal and Taxes (in US$) of Syrian Arab Republic?
Your response must be concise. -3.84e+1. In the year 1997, what is the difference between the Taxes (in US$) of Russian Federation and Taxes (in US$) of St. Kitts and Nevis?
Your answer should be compact. 2.07e+11. In the year 1997, what is the difference between the Taxes (in US$) of Russian Federation and Taxes (in US$) of Syrian Arab Republic?
Ensure brevity in your answer.  1.51e+11. In the year 1997, what is the difference between the Taxes (in US$) in St. Kitts and Nevis and Taxes (in US$) in Syrian Arab Republic?
Keep it short and to the point. -5.62e+1. In the year 1998, what is the difference between the Taxes (in US$) of Nepal and Taxes (in US$) of Russian Federation?
Your answer should be compact. -2.21e+11. In the year 1998, what is the difference between the Taxes (in US$) in Nepal and Taxes (in US$) in St. Kitts and Nevis?
Provide a succinct answer. 1.88e+1. In the year 1998, what is the difference between the Taxes (in US$) in Nepal and Taxes (in US$) in Syrian Arab Republic?
Provide a short and direct response. -1.25e+1. In the year 1998, what is the difference between the Taxes (in US$) in Russian Federation and Taxes (in US$) in St. Kitts and Nevis?
Ensure brevity in your answer.  2.40e+11. In the year 1998, what is the difference between the Taxes (in US$) in Russian Federation and Taxes (in US$) in Syrian Arab Republic?
Your answer should be compact. 2.09e+11. In the year 1998, what is the difference between the Taxes (in US$) of St. Kitts and Nevis and Taxes (in US$) of Syrian Arab Republic?
Provide a short and direct response. -3.14e+1. In the year 1999, what is the difference between the Taxes (in US$) in Nepal and Taxes (in US$) in Russian Federation?
Provide a succinct answer. -4.62e+11. In the year 1999, what is the difference between the Taxes (in US$) in Nepal and Taxes (in US$) in St. Kitts and Nevis?
Make the answer very short. 2.13e+1. In the year 1999, what is the difference between the Taxes (in US$) in Nepal and Taxes (in US$) in Syrian Arab Republic?
Your response must be concise. -1.26e+1. In the year 1999, what is the difference between the Taxes (in US$) of Russian Federation and Taxes (in US$) of St. Kitts and Nevis?
Your answer should be compact. 4.84e+11. In the year 1999, what is the difference between the Taxes (in US$) in Russian Federation and Taxes (in US$) in Syrian Arab Republic?
Give a very brief answer. 4.50e+11. In the year 1999, what is the difference between the Taxes (in US$) of St. Kitts and Nevis and Taxes (in US$) of Syrian Arab Republic?
Your response must be concise. -3.39e+1. In the year 2000, what is the difference between the Taxes (in US$) in Nepal and Taxes (in US$) in Russian Federation?
Provide a succinct answer. -7.51e+11. In the year 2000, what is the difference between the Taxes (in US$) in Nepal and Taxes (in US$) in St. Kitts and Nevis?
Keep it short and to the point. 2.38e+1. In the year 2000, what is the difference between the Taxes (in US$) of Russian Federation and Taxes (in US$) of St. Kitts and Nevis?
Provide a short and direct response. 7.75e+11. What is the ratio of the Taxes (in US$) of Nepal in 1993 to that in 1994?
Make the answer very short. 0.8. What is the ratio of the Taxes (in US$) of Russian Federation in 1993 to that in 1994?
Your response must be concise. 0.32. What is the ratio of the Taxes (in US$) of St. Kitts and Nevis in 1993 to that in 1994?
Ensure brevity in your answer.  0.92. What is the ratio of the Taxes (in US$) in Syrian Arab Republic in 1993 to that in 1994?
Offer a very short reply. 0.77. What is the ratio of the Taxes (in US$) of Nepal in 1993 to that in 1995?
Keep it short and to the point. 0.68. What is the ratio of the Taxes (in US$) of Russian Federation in 1993 to that in 1995?
Ensure brevity in your answer.  0.17. What is the ratio of the Taxes (in US$) of St. Kitts and Nevis in 1993 to that in 1995?
Provide a succinct answer. 0.67. What is the ratio of the Taxes (in US$) of Syrian Arab Republic in 1993 to that in 1995?
Your answer should be compact. 0.67. What is the ratio of the Taxes (in US$) of Nepal in 1993 to that in 1996?
Give a very brief answer. 0.63. What is the ratio of the Taxes (in US$) in Russian Federation in 1993 to that in 1996?
Provide a short and direct response. 0.09. What is the ratio of the Taxes (in US$) in St. Kitts and Nevis in 1993 to that in 1996?
Your response must be concise. 0.6. What is the ratio of the Taxes (in US$) in Syrian Arab Republic in 1993 to that in 1996?
Make the answer very short. 0.79. What is the ratio of the Taxes (in US$) of Nepal in 1993 to that in 1997?
Offer a very short reply. 0.54. What is the ratio of the Taxes (in US$) in Russian Federation in 1993 to that in 1997?
Ensure brevity in your answer.  0.08. What is the ratio of the Taxes (in US$) of St. Kitts and Nevis in 1993 to that in 1997?
Give a very brief answer. 0.54. What is the ratio of the Taxes (in US$) of Syrian Arab Republic in 1993 to that in 1997?
Provide a succinct answer. 0.72. What is the ratio of the Taxes (in US$) of Nepal in 1993 to that in 1998?
Provide a short and direct response. 0.51. What is the ratio of the Taxes (in US$) of Russian Federation in 1993 to that in 1998?
Offer a terse response. 0.06. What is the ratio of the Taxes (in US$) of St. Kitts and Nevis in 1993 to that in 1998?
Ensure brevity in your answer.  0.52. What is the ratio of the Taxes (in US$) in Syrian Arab Republic in 1993 to that in 1998?
Ensure brevity in your answer.  1.3. What is the ratio of the Taxes (in US$) in Nepal in 1993 to that in 1999?
Ensure brevity in your answer.  0.45. What is the ratio of the Taxes (in US$) in Russian Federation in 1993 to that in 1999?
Offer a terse response. 0.03. What is the ratio of the Taxes (in US$) of St. Kitts and Nevis in 1993 to that in 1999?
Provide a short and direct response. 0.49. What is the ratio of the Taxes (in US$) in Syrian Arab Republic in 1993 to that in 1999?
Give a very brief answer. 1.2. What is the ratio of the Taxes (in US$) of Nepal in 1993 to that in 2000?
Keep it short and to the point. 0.41. What is the ratio of the Taxes (in US$) in Russian Federation in 1993 to that in 2000?
Give a very brief answer. 0.02. What is the ratio of the Taxes (in US$) in St. Kitts and Nevis in 1993 to that in 2000?
Your response must be concise. 0.54. What is the ratio of the Taxes (in US$) of Nepal in 1994 to that in 1995?
Your answer should be very brief. 0.85. What is the ratio of the Taxes (in US$) in Russian Federation in 1994 to that in 1995?
Keep it short and to the point. 0.51. What is the ratio of the Taxes (in US$) of St. Kitts and Nevis in 1994 to that in 1995?
Provide a succinct answer. 0.73. What is the ratio of the Taxes (in US$) of Syrian Arab Republic in 1994 to that in 1995?
Provide a succinct answer. 0.87. What is the ratio of the Taxes (in US$) in Nepal in 1994 to that in 1996?
Your answer should be compact. 0.79. What is the ratio of the Taxes (in US$) in Russian Federation in 1994 to that in 1996?
Your answer should be compact. 0.27. What is the ratio of the Taxes (in US$) of St. Kitts and Nevis in 1994 to that in 1996?
Keep it short and to the point. 0.66. What is the ratio of the Taxes (in US$) of Syrian Arab Republic in 1994 to that in 1996?
Offer a terse response. 1.03. What is the ratio of the Taxes (in US$) in Nepal in 1994 to that in 1997?
Your response must be concise. 0.68. What is the ratio of the Taxes (in US$) of Russian Federation in 1994 to that in 1997?
Offer a terse response. 0.23. What is the ratio of the Taxes (in US$) of St. Kitts and Nevis in 1994 to that in 1997?
Give a very brief answer. 0.58. What is the ratio of the Taxes (in US$) of Syrian Arab Republic in 1994 to that in 1997?
Give a very brief answer. 0.94. What is the ratio of the Taxes (in US$) of Nepal in 1994 to that in 1998?
Your answer should be very brief. 0.64. What is the ratio of the Taxes (in US$) of Russian Federation in 1994 to that in 1998?
Give a very brief answer. 0.2. What is the ratio of the Taxes (in US$) of St. Kitts and Nevis in 1994 to that in 1998?
Your answer should be compact. 0.56. What is the ratio of the Taxes (in US$) of Syrian Arab Republic in 1994 to that in 1998?
Provide a succinct answer. 1.69. What is the ratio of the Taxes (in US$) in Nepal in 1994 to that in 1999?
Keep it short and to the point. 0.57. What is the ratio of the Taxes (in US$) of Russian Federation in 1994 to that in 1999?
Provide a short and direct response. 0.1. What is the ratio of the Taxes (in US$) of St. Kitts and Nevis in 1994 to that in 1999?
Your answer should be very brief. 0.54. What is the ratio of the Taxes (in US$) in Syrian Arab Republic in 1994 to that in 1999?
Keep it short and to the point. 1.56. What is the ratio of the Taxes (in US$) in Nepal in 1994 to that in 2000?
Provide a succinct answer. 0.51. What is the ratio of the Taxes (in US$) of Russian Federation in 1994 to that in 2000?
Provide a short and direct response. 0.06. What is the ratio of the Taxes (in US$) of St. Kitts and Nevis in 1994 to that in 2000?
Your answer should be compact. 0.59. What is the ratio of the Taxes (in US$) of Nepal in 1995 to that in 1996?
Offer a terse response. 0.92. What is the ratio of the Taxes (in US$) in Russian Federation in 1995 to that in 1996?
Make the answer very short. 0.54. What is the ratio of the Taxes (in US$) in St. Kitts and Nevis in 1995 to that in 1996?
Provide a succinct answer. 0.9. What is the ratio of the Taxes (in US$) in Syrian Arab Republic in 1995 to that in 1996?
Make the answer very short. 1.19. What is the ratio of the Taxes (in US$) of Nepal in 1995 to that in 1997?
Your answer should be very brief. 0.79. What is the ratio of the Taxes (in US$) of Russian Federation in 1995 to that in 1997?
Provide a succinct answer. 0.45. What is the ratio of the Taxes (in US$) in St. Kitts and Nevis in 1995 to that in 1997?
Your answer should be very brief. 0.8. What is the ratio of the Taxes (in US$) of Syrian Arab Republic in 1995 to that in 1997?
Ensure brevity in your answer.  1.08. What is the ratio of the Taxes (in US$) in Nepal in 1995 to that in 1998?
Your response must be concise. 0.75. What is the ratio of the Taxes (in US$) in Russian Federation in 1995 to that in 1998?
Make the answer very short. 0.39. What is the ratio of the Taxes (in US$) in St. Kitts and Nevis in 1995 to that in 1998?
Offer a terse response. 0.77. What is the ratio of the Taxes (in US$) of Syrian Arab Republic in 1995 to that in 1998?
Give a very brief answer. 1.94. What is the ratio of the Taxes (in US$) in Nepal in 1995 to that in 1999?
Provide a short and direct response. 0.66. What is the ratio of the Taxes (in US$) of Russian Federation in 1995 to that in 1999?
Offer a terse response. 0.19. What is the ratio of the Taxes (in US$) of St. Kitts and Nevis in 1995 to that in 1999?
Your answer should be very brief. 0.73. What is the ratio of the Taxes (in US$) in Syrian Arab Republic in 1995 to that in 1999?
Ensure brevity in your answer.  1.79. What is the ratio of the Taxes (in US$) of Nepal in 1995 to that in 2000?
Give a very brief answer. 0.6. What is the ratio of the Taxes (in US$) of Russian Federation in 1995 to that in 2000?
Your answer should be compact. 0.12. What is the ratio of the Taxes (in US$) in St. Kitts and Nevis in 1995 to that in 2000?
Keep it short and to the point. 0.8. What is the ratio of the Taxes (in US$) in Nepal in 1996 to that in 1997?
Give a very brief answer. 0.86. What is the ratio of the Taxes (in US$) in Russian Federation in 1996 to that in 1997?
Ensure brevity in your answer.  0.84. What is the ratio of the Taxes (in US$) in St. Kitts and Nevis in 1996 to that in 1997?
Offer a very short reply. 0.89. What is the ratio of the Taxes (in US$) in Syrian Arab Republic in 1996 to that in 1997?
Provide a short and direct response. 0.91. What is the ratio of the Taxes (in US$) of Nepal in 1996 to that in 1998?
Give a very brief answer. 0.82. What is the ratio of the Taxes (in US$) in Russian Federation in 1996 to that in 1998?
Your answer should be very brief. 0.73. What is the ratio of the Taxes (in US$) in St. Kitts and Nevis in 1996 to that in 1998?
Give a very brief answer. 0.85. What is the ratio of the Taxes (in US$) in Syrian Arab Republic in 1996 to that in 1998?
Provide a succinct answer. 1.63. What is the ratio of the Taxes (in US$) of Nepal in 1996 to that in 1999?
Your answer should be very brief. 0.72. What is the ratio of the Taxes (in US$) in Russian Federation in 1996 to that in 1999?
Offer a very short reply. 0.36. What is the ratio of the Taxes (in US$) of St. Kitts and Nevis in 1996 to that in 1999?
Offer a very short reply. 0.82. What is the ratio of the Taxes (in US$) of Syrian Arab Republic in 1996 to that in 1999?
Offer a very short reply. 1.51. What is the ratio of the Taxes (in US$) of Nepal in 1996 to that in 2000?
Ensure brevity in your answer.  0.65. What is the ratio of the Taxes (in US$) in Russian Federation in 1996 to that in 2000?
Provide a succinct answer. 0.23. What is the ratio of the Taxes (in US$) of St. Kitts and Nevis in 1996 to that in 2000?
Your answer should be very brief. 0.89. What is the ratio of the Taxes (in US$) of Nepal in 1997 to that in 1998?
Provide a succinct answer. 0.95. What is the ratio of the Taxes (in US$) in Russian Federation in 1997 to that in 1998?
Give a very brief answer. 0.86. What is the ratio of the Taxes (in US$) of St. Kitts and Nevis in 1997 to that in 1998?
Ensure brevity in your answer.  0.96. What is the ratio of the Taxes (in US$) in Syrian Arab Republic in 1997 to that in 1998?
Ensure brevity in your answer.  1.79. What is the ratio of the Taxes (in US$) in Nepal in 1997 to that in 1999?
Offer a terse response. 0.84. What is the ratio of the Taxes (in US$) in Russian Federation in 1997 to that in 1999?
Ensure brevity in your answer.  0.43. What is the ratio of the Taxes (in US$) of St. Kitts and Nevis in 1997 to that in 1999?
Your answer should be very brief. 0.92. What is the ratio of the Taxes (in US$) of Syrian Arab Republic in 1997 to that in 1999?
Provide a short and direct response. 1.66. What is the ratio of the Taxes (in US$) in Nepal in 1997 to that in 2000?
Offer a terse response. 0.75. What is the ratio of the Taxes (in US$) of Russian Federation in 1997 to that in 2000?
Give a very brief answer. 0.27. What is the ratio of the Taxes (in US$) in St. Kitts and Nevis in 1997 to that in 2000?
Offer a terse response. 1. What is the ratio of the Taxes (in US$) of Nepal in 1998 to that in 1999?
Provide a short and direct response. 0.88. What is the ratio of the Taxes (in US$) in Russian Federation in 1998 to that in 1999?
Provide a short and direct response. 0.5. What is the ratio of the Taxes (in US$) of St. Kitts and Nevis in 1998 to that in 1999?
Your answer should be compact. 0.96. What is the ratio of the Taxes (in US$) of Syrian Arab Republic in 1998 to that in 1999?
Keep it short and to the point. 0.92. What is the ratio of the Taxes (in US$) of Nepal in 1998 to that in 2000?
Provide a short and direct response. 0.79. What is the ratio of the Taxes (in US$) of Russian Federation in 1998 to that in 2000?
Offer a terse response. 0.31. What is the ratio of the Taxes (in US$) in St. Kitts and Nevis in 1998 to that in 2000?
Your answer should be very brief. 1.04. What is the ratio of the Taxes (in US$) of Nepal in 1999 to that in 2000?
Provide a succinct answer. 0.9. What is the ratio of the Taxes (in US$) of Russian Federation in 1999 to that in 2000?
Ensure brevity in your answer.  0.62. What is the ratio of the Taxes (in US$) of St. Kitts and Nevis in 1999 to that in 2000?
Offer a terse response. 1.09. What is the difference between the highest and the second highest Taxes (in US$) in Nepal?
Offer a terse response. 2.49e+09. What is the difference between the highest and the second highest Taxes (in US$) of Russian Federation?
Your answer should be compact. 2.91e+11. What is the difference between the highest and the second highest Taxes (in US$) of St. Kitts and Nevis?
Provide a succinct answer. 5.56e+06. What is the difference between the highest and the second highest Taxes (in US$) in Syrian Arab Republic?
Your answer should be compact. 4.68e+09. What is the difference between the highest and the lowest Taxes (in US$) in Nepal?
Give a very brief answer. 1.42e+1. What is the difference between the highest and the lowest Taxes (in US$) in Russian Federation?
Offer a very short reply. 7.60e+11. What is the difference between the highest and the lowest Taxes (in US$) of St. Kitts and Nevis?
Your response must be concise. 6.53e+07. What is the difference between the highest and the lowest Taxes (in US$) of Syrian Arab Republic?
Offer a very short reply. 6.10e+1. 